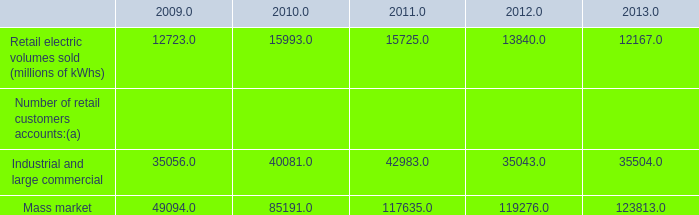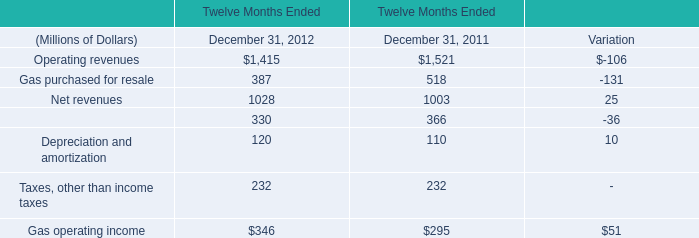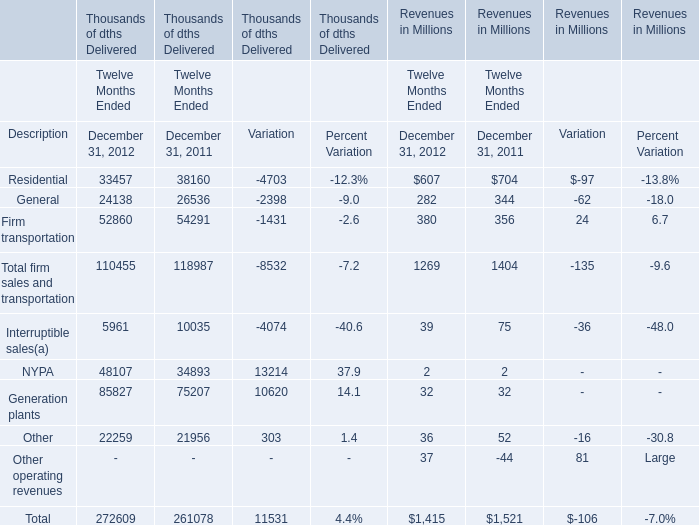What was the average value of Residential Revenues, General Revenues, Firm transportation Revenues in 2011 ? (in million) 
Computations: (((704 + 344) + 356) / 3)
Answer: 468.0. 